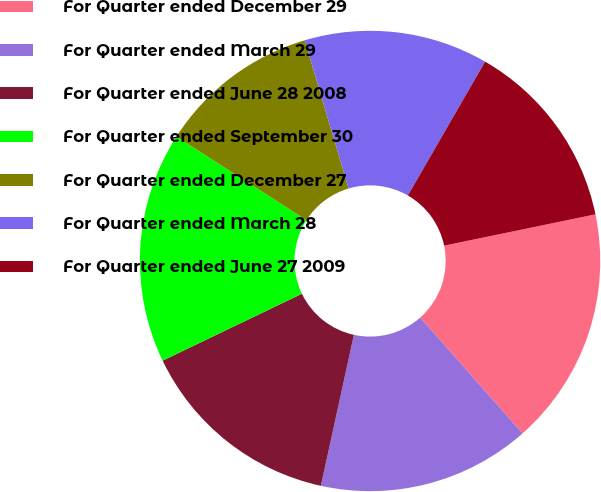<chart> <loc_0><loc_0><loc_500><loc_500><pie_chart><fcel>For Quarter ended December 29<fcel>For Quarter ended March 29<fcel>For Quarter ended June 28 2008<fcel>For Quarter ended September 30<fcel>For Quarter ended December 27<fcel>For Quarter ended March 28<fcel>For Quarter ended June 27 2009<nl><fcel>16.72%<fcel>14.95%<fcel>14.44%<fcel>16.21%<fcel>11.33%<fcel>12.91%<fcel>13.42%<nl></chart> 